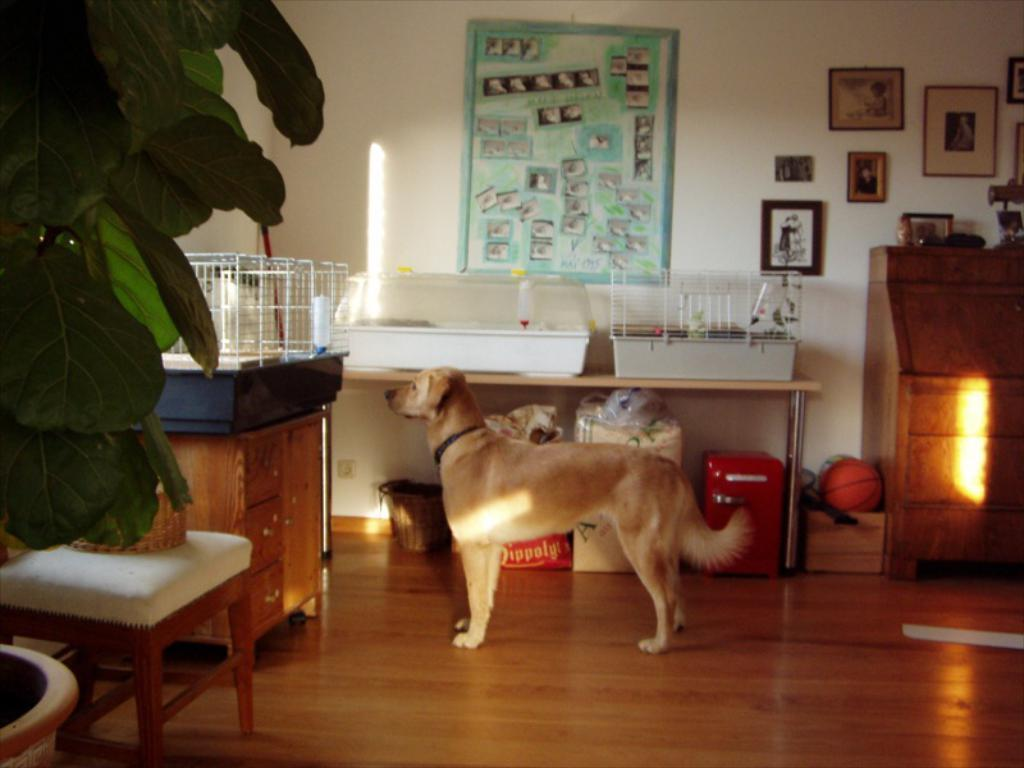What animal can be seen in the image? There is a dog standing in the image. What is on the wall behind the dog? There are photo frames on the wall behind the dog. What can be found in the left corner of the image? There is a plant and a chair in the left corner of the image. What type of wood is burning in the fireplace in the image? There is no fireplace or wood present in the image. Who is the stranger standing next to the dog in the image? There is no stranger present in the image; only the dog can be seen. 